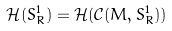Convert formula to latex. <formula><loc_0><loc_0><loc_500><loc_500>\mathcal { H } ( S ^ { 1 } _ { R } ) = \mathcal { H } ( \mathcal { C } ( M , S ^ { 1 } _ { R } ) )</formula> 